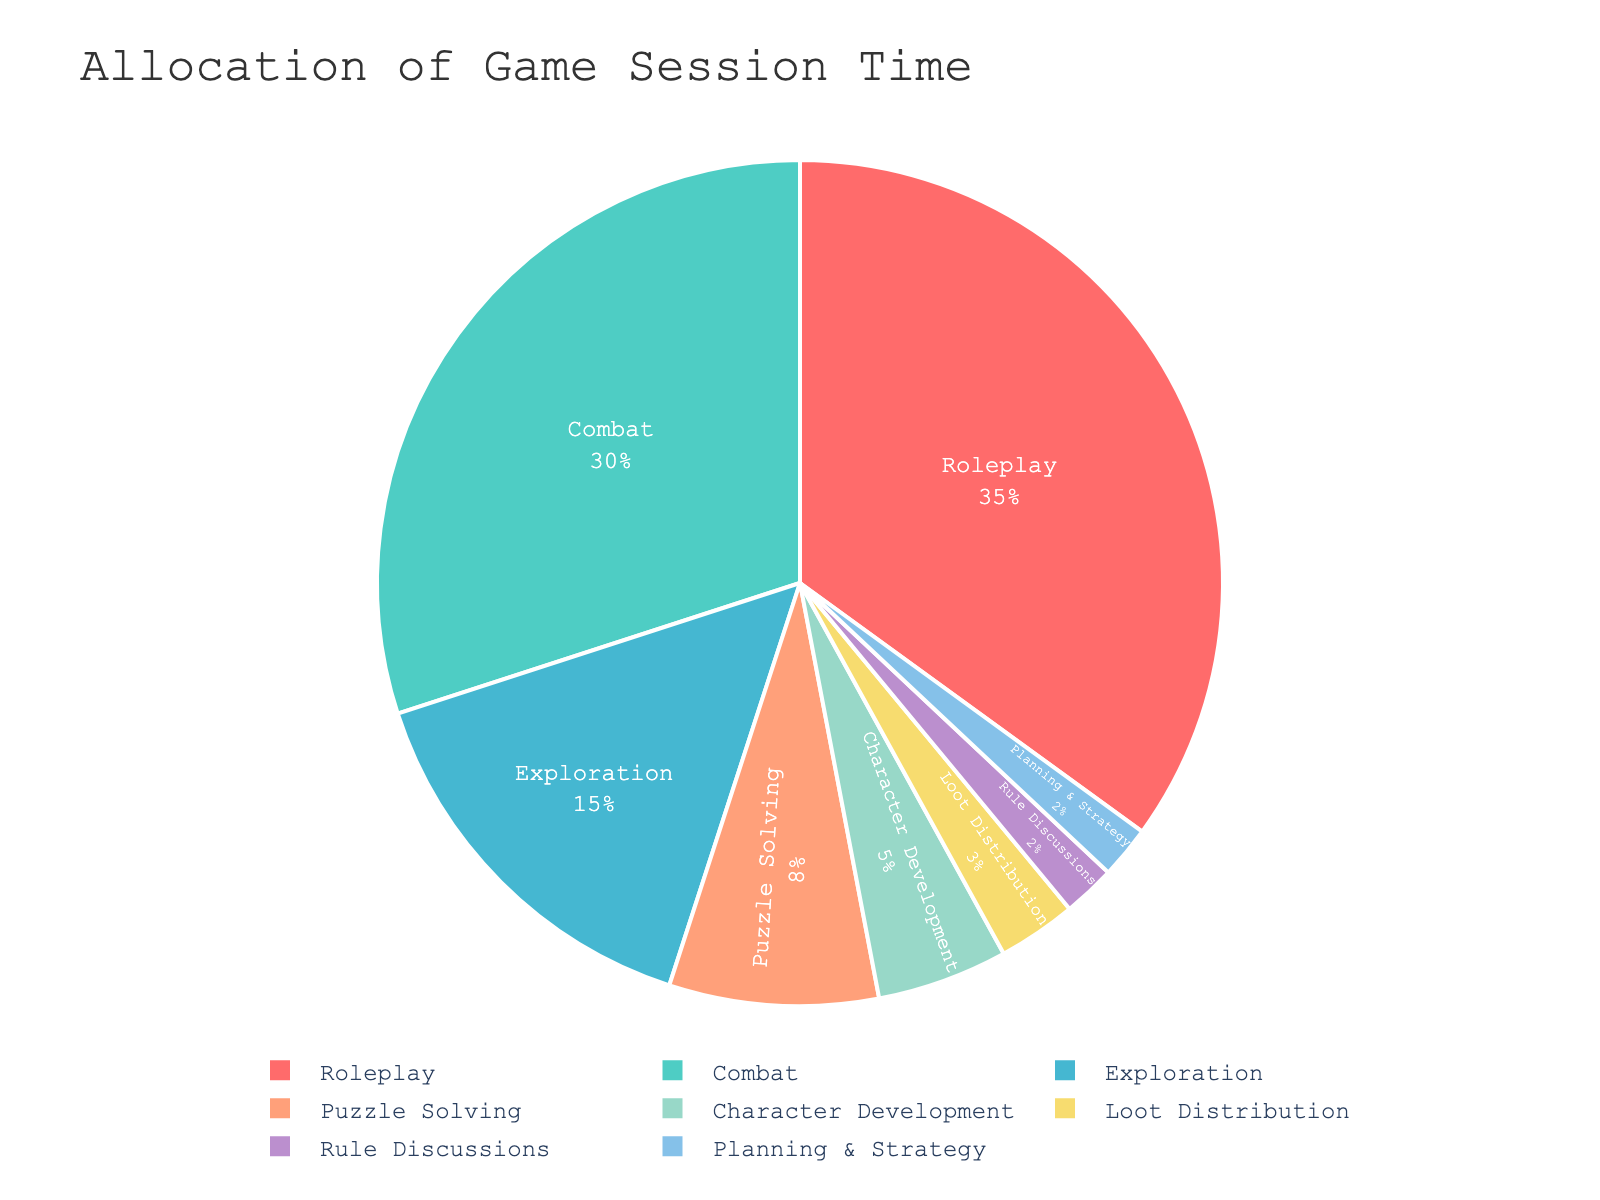what percentage of time is allocated to combat? By referring to the chart, the slice labeled "Combat" shows 30% of the total time.
Answer: 30% which activity uses more time, exploration or puzzle solving? By comparing the slices labeled "Exploration" and "Puzzle Solving," the chart shows 15% for Exploration and 8% for Puzzle Solving. Since 15% is greater than 8%, Exploration uses more time.
Answer: Exploration how much less time is allocated to loot distribution compared to character development? From the chart, "Loot Distribution" is 3% and "Character Development" is 5%. The difference is 5% - 3% = 2%.
Answer: 2% what is the combined percentage of time spent on rule discussions and planning & strategy? From the chart, "Rule Discussions" is 2% and "Planning & Strategy" is also 2%. The combined percentage is 2% + 2% = 4%.
Answer: 4% which activity has the second highest percentage allocation? By examining the chart, the highest percentage is for "Roleplay" at 35%, and the second highest is "Combat" at 30%.
Answer: Combat what is the total percentage of time allocated to categories other than combat, roleplay, and exploration? From the chart, the percentages for Combat (30%), Roleplay (35%), and Exploration (15%) add up to 80%. Therefore, the remaining percentage is 100% - 80% = 20%.
Answer: 20% are there more activities allocated 10% or more, or less than 10% of the time? The activities with 10% or more are Combat (30%), Roleplay (35%), and Exploration (15%), totaling 3 activities. The activities with less than 10% are Puzzle Solving (8%), Character Development (5%), Loot Distribution (3%), Rule Discussions (2%), and Planning & Strategy (2%), totaling 5 activities. There are more activities with less than 10%.
Answer: Less than 10% what activity is represented by the green slice? The color representation in the chart shows green corresponds to the second highest percentage, which is "Combat" at 30%.
Answer: Combat 